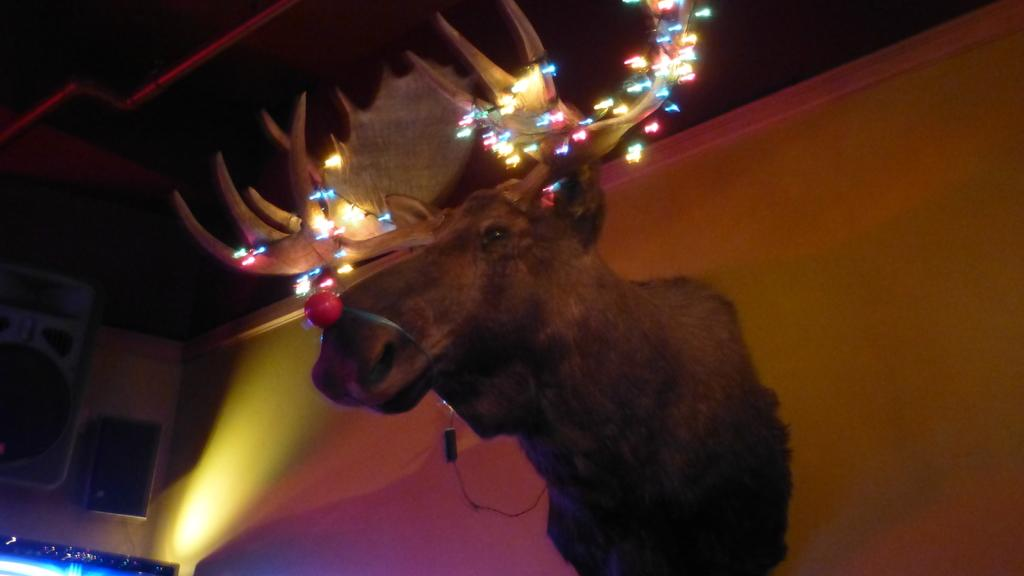What is depicted on the wall in the image? There is a statue of an animal on the wall in the image. What feature does the statue have? The statue has decorative lights on its horns. What can be seen in the background of the image? There are speakers, lights, and other unspecified objects in the background of the image. Can you see any grass growing around the statue in the image? There is no grass visible in the image; it features a statue on a wall with decorative lights and objects in the background. 